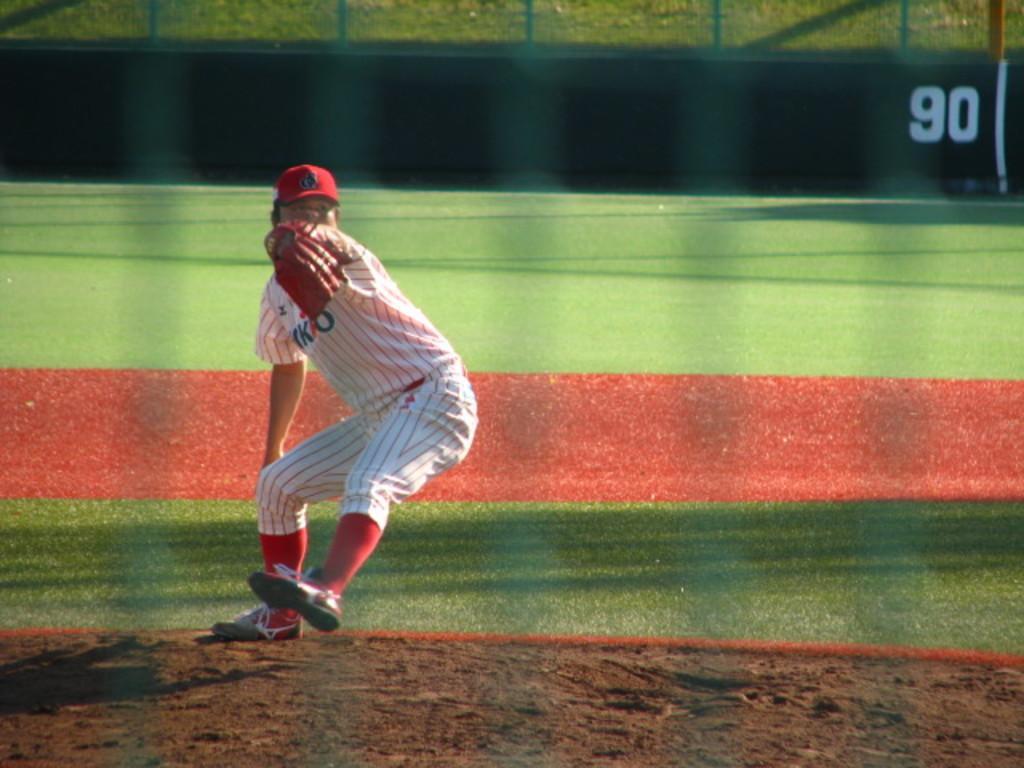How would you summarize this image in a sentence or two? In the image there is a baseball player, he is in the playing position and behind the player there is a ground. 